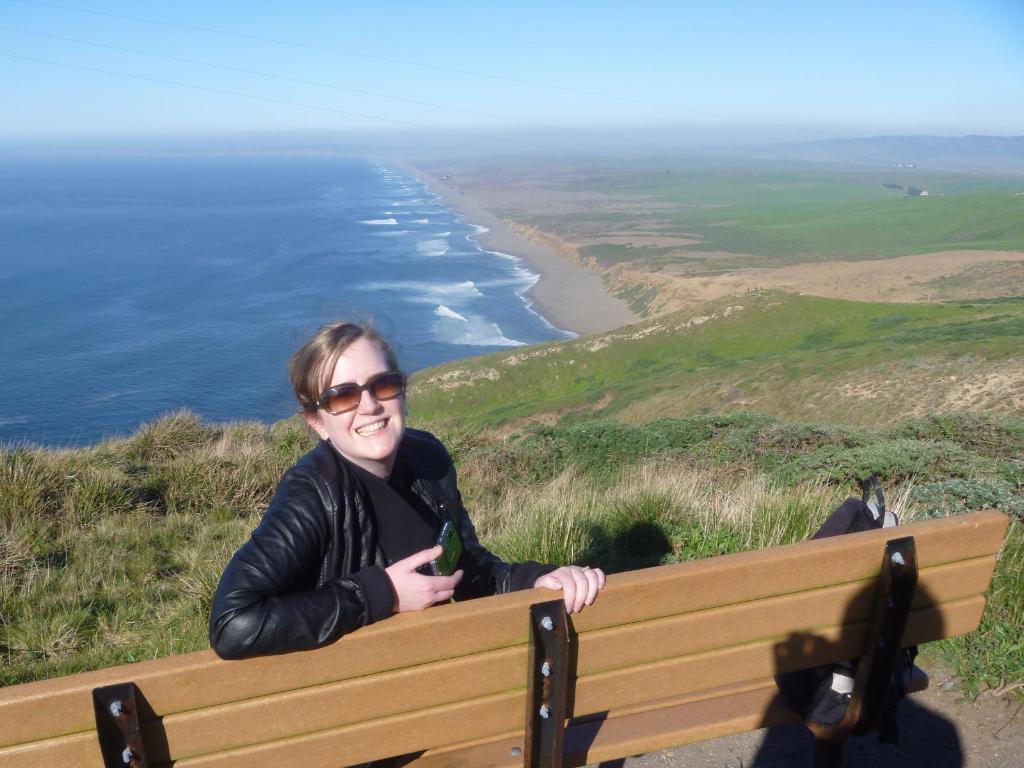How would you summarize this image in a sentence or two? In the image we can see there is a woman sitting on the bench and wearing black colour jacket and sunglasses. Behind there is water and the ground is covered with grass. 